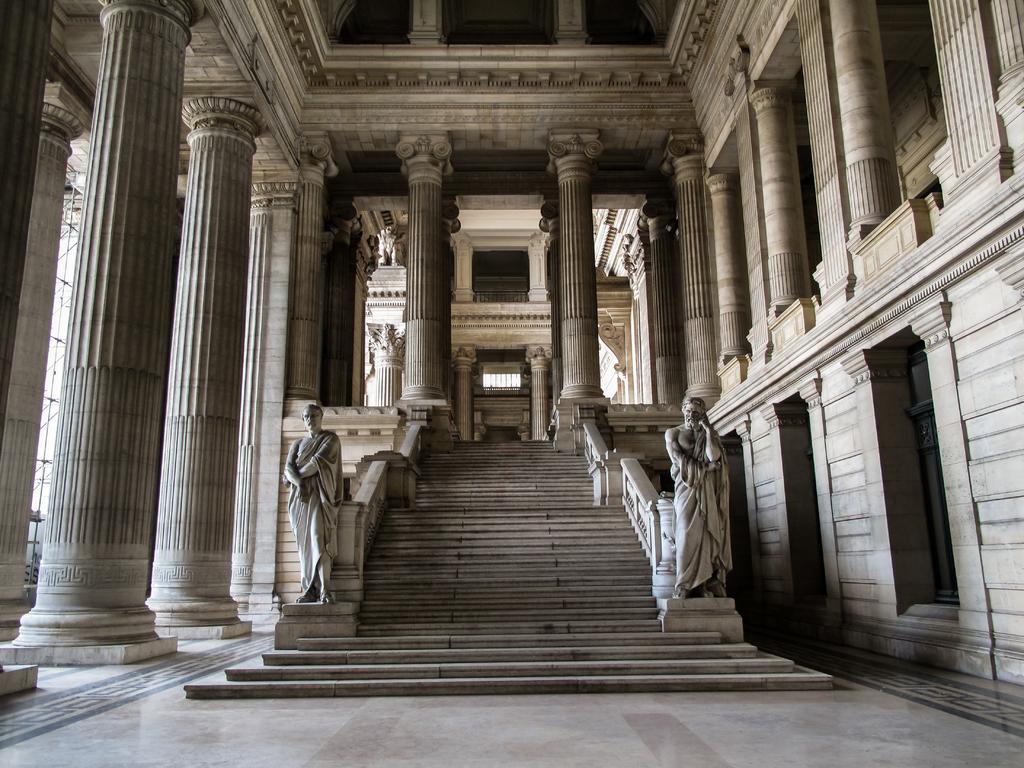In one or two sentences, can you explain what this image depicts? In the center of the image there are stairs. Beside the stairs there are statues, pillars and there are some engravings on the walls. At the bottom of the image there is a floor. 